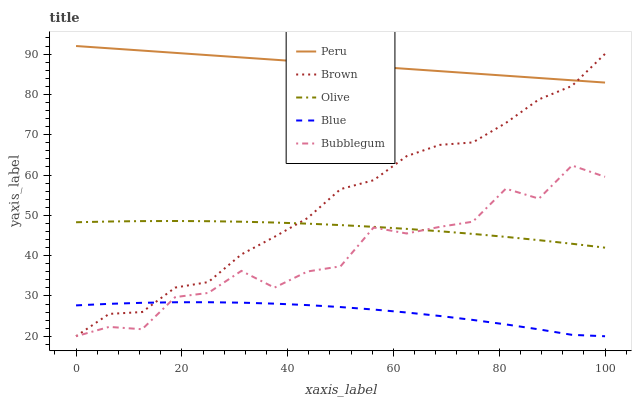Does Brown have the minimum area under the curve?
Answer yes or no. No. Does Brown have the maximum area under the curve?
Answer yes or no. No. Is Brown the smoothest?
Answer yes or no. No. Is Brown the roughest?
Answer yes or no. No. Does Peru have the lowest value?
Answer yes or no. No. Does Brown have the highest value?
Answer yes or no. No. Is Blue less than Peru?
Answer yes or no. Yes. Is Peru greater than Olive?
Answer yes or no. Yes. Does Blue intersect Peru?
Answer yes or no. No. 